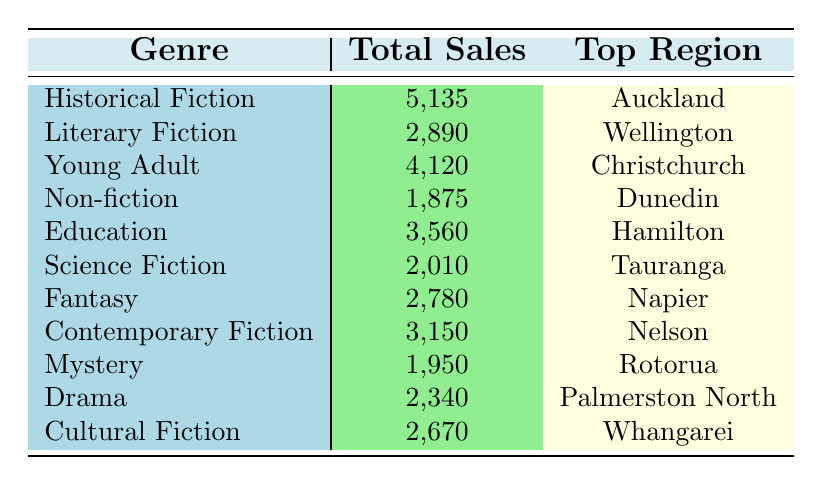What genre had the highest total sales? By looking at the total sales column, Historical Fiction has 5,135 which is higher than all other genres.
Answer: Historical Fiction Which region had the highest sales for Young Adult genre? According to the table, Christchurch is listed as the top region for the Young Adult genre with sales of 4,120.
Answer: Christchurch What is the total sales of Non-fiction and Mystery combined? The total sales for Non-fiction is 1,875 and for Mystery is 1,950. Adding them gives 1,875 + 1,950 = 3,825.
Answer: 3,825 Is the top region for Science Fiction greater than the top region for Drama in terms of sales? The top region for Science Fiction is Tauranga with 2,010 sales and for Drama it is Palmerston North with 2,340 sales. Since 2,010 is less than 2,340, the answer is no.
Answer: No What is the average sales for genres that have 2,000 or more sales? The genres with sales of 2,000 or more are Historical Fiction (5,135), Young Adult (4,120), Education (3,560), Contemporary Fiction (3,150), Drama (2,340), and Cultural Fiction (2,670). Summing their sales gives 5,135 + 4,120 + 3,560 + 3,150 + 2,340 + 2,670 = 21,975. There are 6 genres in total, so the average is 21,975/6 = 3,662.5.
Answer: 3,662.5 Which genre has the lowest sales? The table shows that Non-fiction has the lowest sales at 1,875, which is lower than all other genres listed.
Answer: Non-fiction 